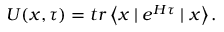<formula> <loc_0><loc_0><loc_500><loc_500>U ( x , \tau ) = t r \left \langle x | e ^ { H \tau } | x \right \rangle .</formula> 